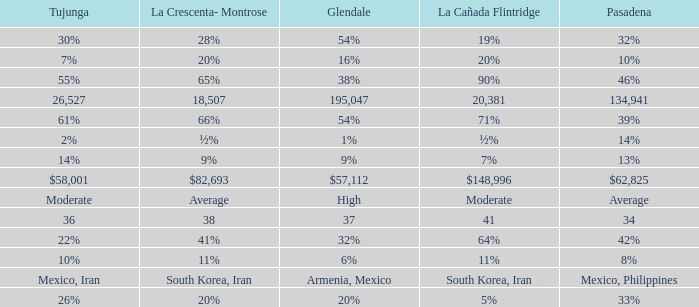I'm looking to parse the entire table for insights. Could you assist me with that? {'header': ['Tujunga', 'La Crescenta- Montrose', 'Glendale', 'La Cañada Flintridge', 'Pasadena'], 'rows': [['30%', '28%', '54%', '19%', '32%'], ['7%', '20%', '16%', '20%', '10%'], ['55%', '65%', '38%', '90%', '46%'], ['26,527', '18,507', '195,047', '20,381', '134,941'], ['61%', '66%', '54%', '71%', '39%'], ['2%', '½%', '1%', '½%', '14%'], ['14%', '9%', '9%', '7%', '13%'], ['$58,001', '$82,693', '$57,112', '$148,996', '$62,825'], ['Moderate', 'Average', 'High', 'Moderate', 'Average'], ['36', '38', '37', '41', '34'], ['22%', '41%', '32%', '64%', '42%'], ['10%', '11%', '6%', '11%', '8%'], ['Mexico, Iran', 'South Korea, Iran', 'Armenia, Mexico', 'South Korea, Iran', 'Mexico, Philippines'], ['26%', '20%', '20%', '5%', '33%']]} When Pasadena is at 10%, what is La Crescenta-Montrose? 20%. 